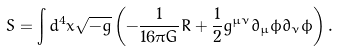<formula> <loc_0><loc_0><loc_500><loc_500>S = \int d ^ { 4 } x \sqrt { - g } \left ( - \frac { 1 } { 1 6 \pi G } R + \frac { 1 } { 2 } g ^ { \mu \nu } \partial _ { \mu } \phi \partial _ { \nu } \phi \right ) .</formula> 